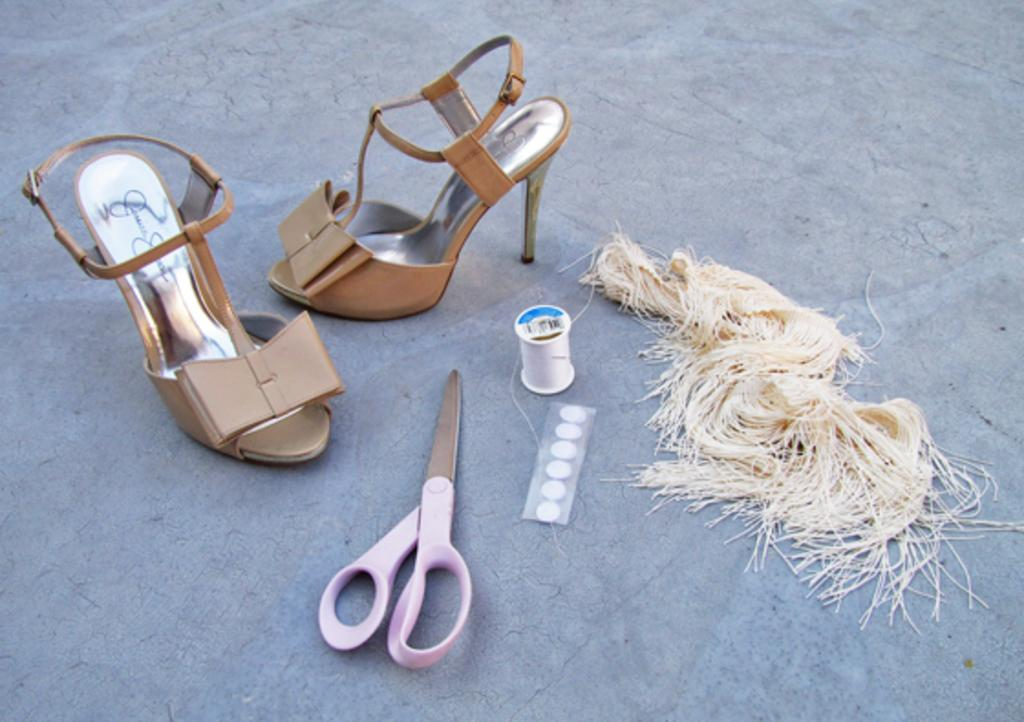What type of tool is visible in the image? There is a scissor in the image. What type of footwear can be seen in the image? There are sandals in the image. What material is present in the image that is typically used for sewing? There are threads in the image. Are there any other objects present in the image besides the scissor, sandals, and threads? Yes, there are other objects in the image. Where are all of these objects located in the image? All of these objects are placed on the floor. Can you tell me who won the argument that took place on the shelf in the image? There is no argument or shelf present in the image; it only features objects placed on the floor. 